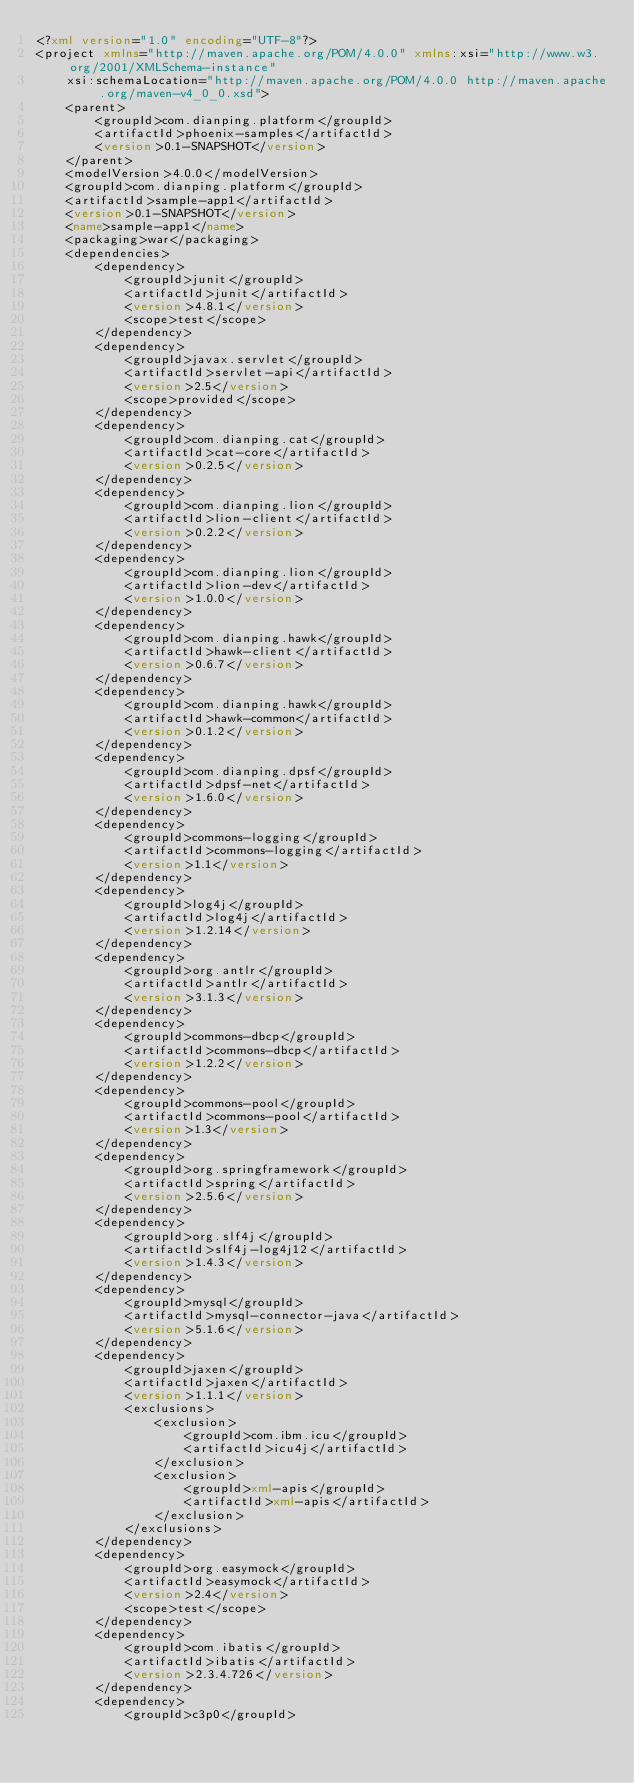Convert code to text. <code><loc_0><loc_0><loc_500><loc_500><_XML_><?xml version="1.0" encoding="UTF-8"?>
<project xmlns="http://maven.apache.org/POM/4.0.0" xmlns:xsi="http://www.w3.org/2001/XMLSchema-instance"
	xsi:schemaLocation="http://maven.apache.org/POM/4.0.0 http://maven.apache.org/maven-v4_0_0.xsd">
	<parent>
		<groupId>com.dianping.platform</groupId>
		<artifactId>phoenix-samples</artifactId>
		<version>0.1-SNAPSHOT</version>
	</parent>
	<modelVersion>4.0.0</modelVersion>
	<groupId>com.dianping.platform</groupId>
	<artifactId>sample-app1</artifactId>
	<version>0.1-SNAPSHOT</version>
	<name>sample-app1</name>
	<packaging>war</packaging>
	<dependencies>
		<dependency>
			<groupId>junit</groupId>
			<artifactId>junit</artifactId>
			<version>4.8.1</version>
			<scope>test</scope>
		</dependency>
		<dependency>
			<groupId>javax.servlet</groupId>
			<artifactId>servlet-api</artifactId>
			<version>2.5</version>
			<scope>provided</scope>
		</dependency>
		<dependency>
			<groupId>com.dianping.cat</groupId>
			<artifactId>cat-core</artifactId>
			<version>0.2.5</version>
		</dependency>
		<dependency>
			<groupId>com.dianping.lion</groupId>
			<artifactId>lion-client</artifactId>
			<version>0.2.2</version>
		</dependency>
		<dependency>
			<groupId>com.dianping.lion</groupId>
			<artifactId>lion-dev</artifactId>
			<version>1.0.0</version>
		</dependency>
		<dependency>
			<groupId>com.dianping.hawk</groupId>
			<artifactId>hawk-client</artifactId>
			<version>0.6.7</version>
		</dependency>
		<dependency>
			<groupId>com.dianping.hawk</groupId>
			<artifactId>hawk-common</artifactId>
			<version>0.1.2</version>
		</dependency>
		<dependency>
			<groupId>com.dianping.dpsf</groupId>
			<artifactId>dpsf-net</artifactId>
			<version>1.6.0</version>
		</dependency>
		<dependency>
			<groupId>commons-logging</groupId>
			<artifactId>commons-logging</artifactId>
			<version>1.1</version>
		</dependency>
		<dependency>
			<groupId>log4j</groupId>
			<artifactId>log4j</artifactId>
			<version>1.2.14</version>
		</dependency>
		<dependency>
			<groupId>org.antlr</groupId>
			<artifactId>antlr</artifactId>
			<version>3.1.3</version>
		</dependency>
		<dependency>
			<groupId>commons-dbcp</groupId>
			<artifactId>commons-dbcp</artifactId>
			<version>1.2.2</version>
		</dependency>
		<dependency>
			<groupId>commons-pool</groupId>
			<artifactId>commons-pool</artifactId>
			<version>1.3</version>
		</dependency>
		<dependency>
			<groupId>org.springframework</groupId>
			<artifactId>spring</artifactId>
			<version>2.5.6</version>
		</dependency>
		<dependency>
			<groupId>org.slf4j</groupId>
			<artifactId>slf4j-log4j12</artifactId>
			<version>1.4.3</version>
		</dependency>
		<dependency>
			<groupId>mysql</groupId>
			<artifactId>mysql-connector-java</artifactId>
			<version>5.1.6</version>
		</dependency>
		<dependency>
			<groupId>jaxen</groupId>
			<artifactId>jaxen</artifactId>
			<version>1.1.1</version>
			<exclusions>
				<exclusion>
					<groupId>com.ibm.icu</groupId>
					<artifactId>icu4j</artifactId>
				</exclusion>
				<exclusion>
					<groupId>xml-apis</groupId>
					<artifactId>xml-apis</artifactId>
				</exclusion>
			</exclusions>
		</dependency>
		<dependency>
			<groupId>org.easymock</groupId>
			<artifactId>easymock</artifactId>
			<version>2.4</version>
			<scope>test</scope>
		</dependency>
		<dependency>
			<groupId>com.ibatis</groupId>
			<artifactId>ibatis</artifactId>
			<version>2.3.4.726</version>
		</dependency>
		<dependency>
			<groupId>c3p0</groupId></code> 